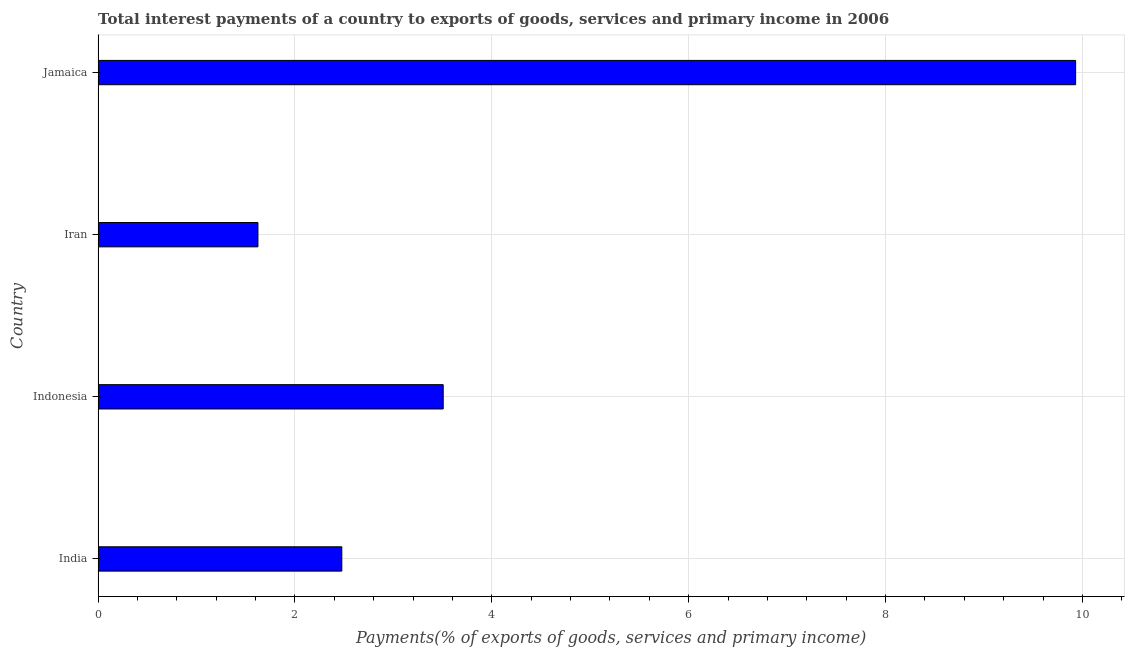Does the graph contain any zero values?
Offer a terse response. No. What is the title of the graph?
Offer a terse response. Total interest payments of a country to exports of goods, services and primary income in 2006. What is the label or title of the X-axis?
Your response must be concise. Payments(% of exports of goods, services and primary income). What is the label or title of the Y-axis?
Provide a short and direct response. Country. What is the total interest payments on external debt in Iran?
Ensure brevity in your answer.  1.62. Across all countries, what is the maximum total interest payments on external debt?
Give a very brief answer. 9.93. Across all countries, what is the minimum total interest payments on external debt?
Provide a succinct answer. 1.62. In which country was the total interest payments on external debt maximum?
Your response must be concise. Jamaica. In which country was the total interest payments on external debt minimum?
Give a very brief answer. Iran. What is the sum of the total interest payments on external debt?
Provide a succinct answer. 17.54. What is the difference between the total interest payments on external debt in Indonesia and Iran?
Keep it short and to the point. 1.88. What is the average total interest payments on external debt per country?
Provide a succinct answer. 4.38. What is the median total interest payments on external debt?
Ensure brevity in your answer.  2.99. In how many countries, is the total interest payments on external debt greater than 2 %?
Provide a short and direct response. 3. What is the ratio of the total interest payments on external debt in India to that in Iran?
Make the answer very short. 1.52. What is the difference between the highest and the second highest total interest payments on external debt?
Provide a short and direct response. 6.42. What is the difference between the highest and the lowest total interest payments on external debt?
Your answer should be very brief. 8.31. In how many countries, is the total interest payments on external debt greater than the average total interest payments on external debt taken over all countries?
Keep it short and to the point. 1. Are all the bars in the graph horizontal?
Offer a very short reply. Yes. How many countries are there in the graph?
Give a very brief answer. 4. What is the difference between two consecutive major ticks on the X-axis?
Your response must be concise. 2. Are the values on the major ticks of X-axis written in scientific E-notation?
Provide a short and direct response. No. What is the Payments(% of exports of goods, services and primary income) of India?
Offer a terse response. 2.48. What is the Payments(% of exports of goods, services and primary income) of Indonesia?
Your answer should be very brief. 3.51. What is the Payments(% of exports of goods, services and primary income) of Iran?
Offer a terse response. 1.62. What is the Payments(% of exports of goods, services and primary income) in Jamaica?
Make the answer very short. 9.93. What is the difference between the Payments(% of exports of goods, services and primary income) in India and Indonesia?
Offer a very short reply. -1.03. What is the difference between the Payments(% of exports of goods, services and primary income) in India and Iran?
Your answer should be compact. 0.85. What is the difference between the Payments(% of exports of goods, services and primary income) in India and Jamaica?
Provide a succinct answer. -7.46. What is the difference between the Payments(% of exports of goods, services and primary income) in Indonesia and Iran?
Offer a very short reply. 1.88. What is the difference between the Payments(% of exports of goods, services and primary income) in Indonesia and Jamaica?
Your answer should be compact. -6.43. What is the difference between the Payments(% of exports of goods, services and primary income) in Iran and Jamaica?
Provide a succinct answer. -8.31. What is the ratio of the Payments(% of exports of goods, services and primary income) in India to that in Indonesia?
Provide a short and direct response. 0.71. What is the ratio of the Payments(% of exports of goods, services and primary income) in India to that in Iran?
Your response must be concise. 1.52. What is the ratio of the Payments(% of exports of goods, services and primary income) in India to that in Jamaica?
Give a very brief answer. 0.25. What is the ratio of the Payments(% of exports of goods, services and primary income) in Indonesia to that in Iran?
Provide a short and direct response. 2.16. What is the ratio of the Payments(% of exports of goods, services and primary income) in Indonesia to that in Jamaica?
Your response must be concise. 0.35. What is the ratio of the Payments(% of exports of goods, services and primary income) in Iran to that in Jamaica?
Your answer should be very brief. 0.16. 